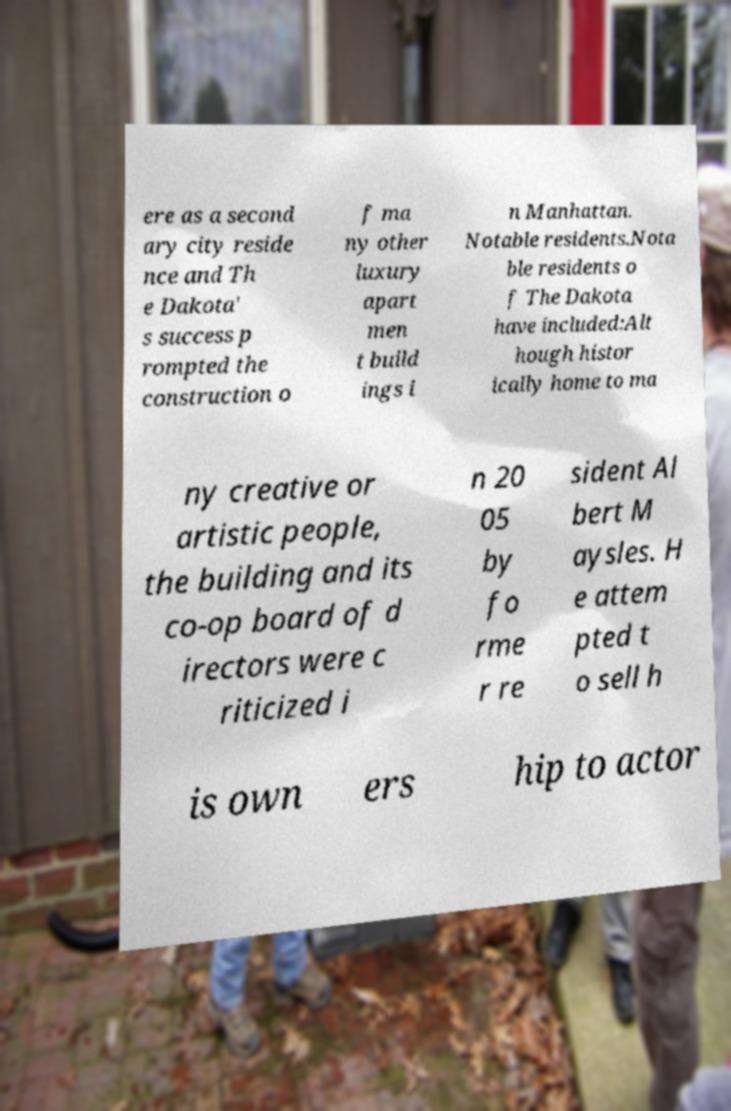Could you extract and type out the text from this image? ere as a second ary city reside nce and Th e Dakota' s success p rompted the construction o f ma ny other luxury apart men t build ings i n Manhattan. Notable residents.Nota ble residents o f The Dakota have included:Alt hough histor ically home to ma ny creative or artistic people, the building and its co-op board of d irectors were c riticized i n 20 05 by fo rme r re sident Al bert M aysles. H e attem pted t o sell h is own ers hip to actor 